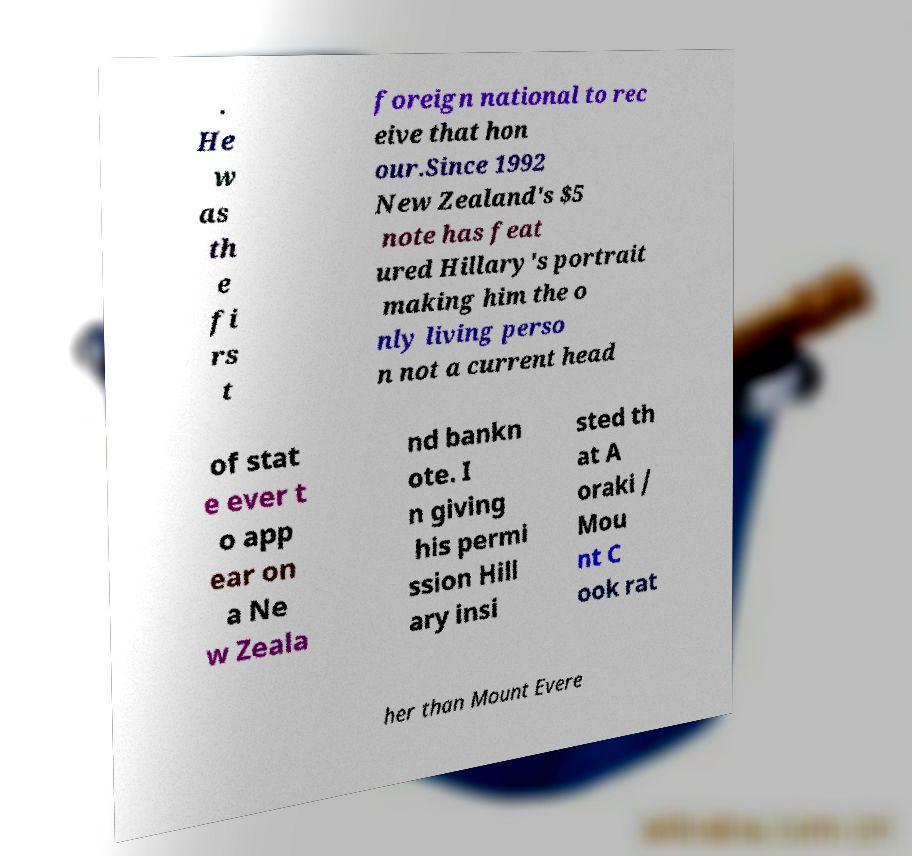What messages or text are displayed in this image? I need them in a readable, typed format. . He w as th e fi rs t foreign national to rec eive that hon our.Since 1992 New Zealand's $5 note has feat ured Hillary's portrait making him the o nly living perso n not a current head of stat e ever t o app ear on a Ne w Zeala nd bankn ote. I n giving his permi ssion Hill ary insi sted th at A oraki / Mou nt C ook rat her than Mount Evere 